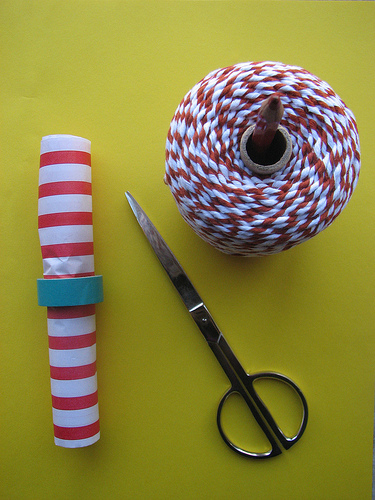<image>
Is there a string above the scissors? Yes. The string is positioned above the scissors in the vertical space, higher up in the scene. Is the scissor in front of the yarn? No. The scissor is not in front of the yarn. The spatial positioning shows a different relationship between these objects. 